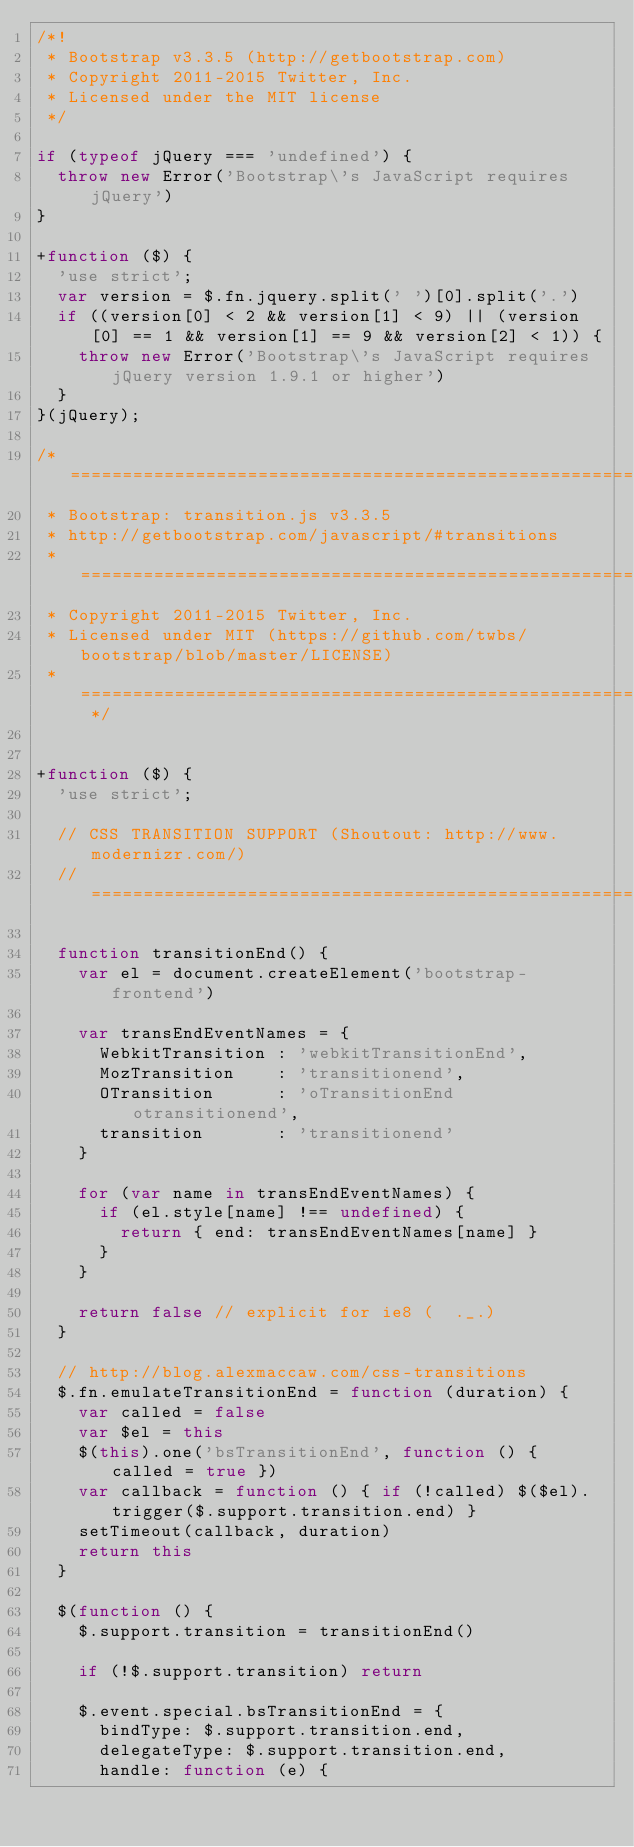<code> <loc_0><loc_0><loc_500><loc_500><_JavaScript_>/*!
 * Bootstrap v3.3.5 (http://getbootstrap.com)
 * Copyright 2011-2015 Twitter, Inc.
 * Licensed under the MIT license
 */

if (typeof jQuery === 'undefined') {
  throw new Error('Bootstrap\'s JavaScript requires jQuery')
}

+function ($) {
  'use strict';
  var version = $.fn.jquery.split(' ')[0].split('.')
  if ((version[0] < 2 && version[1] < 9) || (version[0] == 1 && version[1] == 9 && version[2] < 1)) {
    throw new Error('Bootstrap\'s JavaScript requires jQuery version 1.9.1 or higher')
  }
}(jQuery);

/* ========================================================================
 * Bootstrap: transition.js v3.3.5
 * http://getbootstrap.com/javascript/#transitions
 * ========================================================================
 * Copyright 2011-2015 Twitter, Inc.
 * Licensed under MIT (https://github.com/twbs/bootstrap/blob/master/LICENSE)
 * ======================================================================== */


+function ($) {
  'use strict';

  // CSS TRANSITION SUPPORT (Shoutout: http://www.modernizr.com/)
  // ============================================================

  function transitionEnd() {
    var el = document.createElement('bootstrap-frontend')

    var transEndEventNames = {
      WebkitTransition : 'webkitTransitionEnd',
      MozTransition    : 'transitionend',
      OTransition      : 'oTransitionEnd otransitionend',
      transition       : 'transitionend'
    }

    for (var name in transEndEventNames) {
      if (el.style[name] !== undefined) {
        return { end: transEndEventNames[name] }
      }
    }

    return false // explicit for ie8 (  ._.)
  }

  // http://blog.alexmaccaw.com/css-transitions
  $.fn.emulateTransitionEnd = function (duration) {
    var called = false
    var $el = this
    $(this).one('bsTransitionEnd', function () { called = true })
    var callback = function () { if (!called) $($el).trigger($.support.transition.end) }
    setTimeout(callback, duration)
    return this
  }

  $(function () {
    $.support.transition = transitionEnd()

    if (!$.support.transition) return

    $.event.special.bsTransitionEnd = {
      bindType: $.support.transition.end,
      delegateType: $.support.transition.end,
      handle: function (e) {</code> 